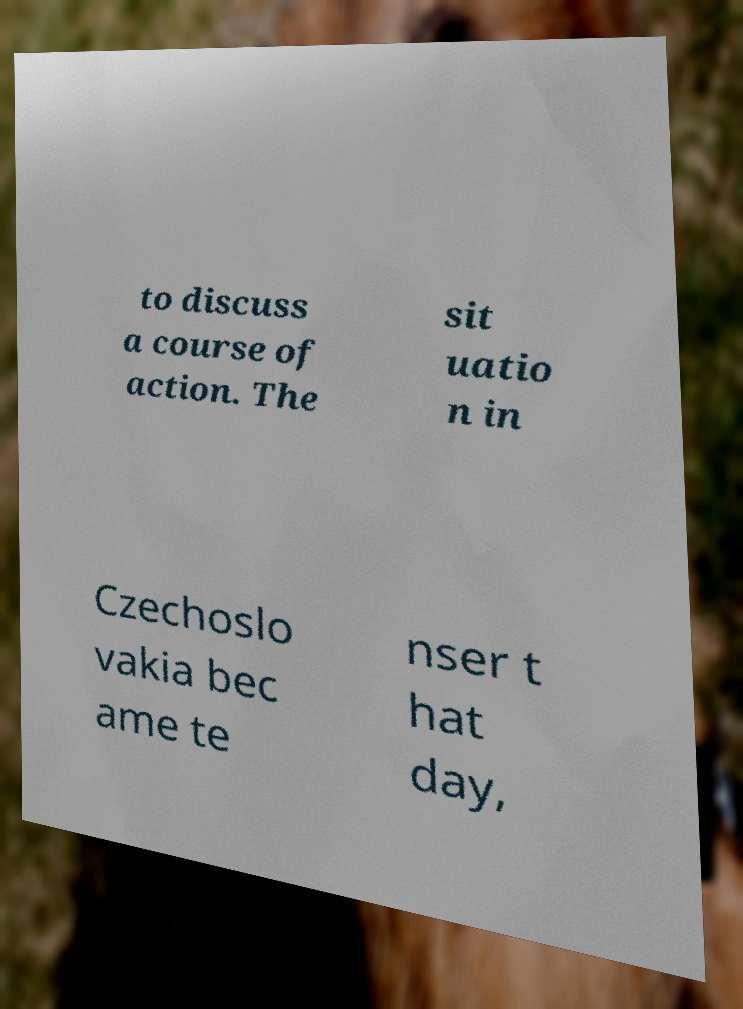What messages or text are displayed in this image? I need them in a readable, typed format. to discuss a course of action. The sit uatio n in Czechoslo vakia bec ame te nser t hat day, 